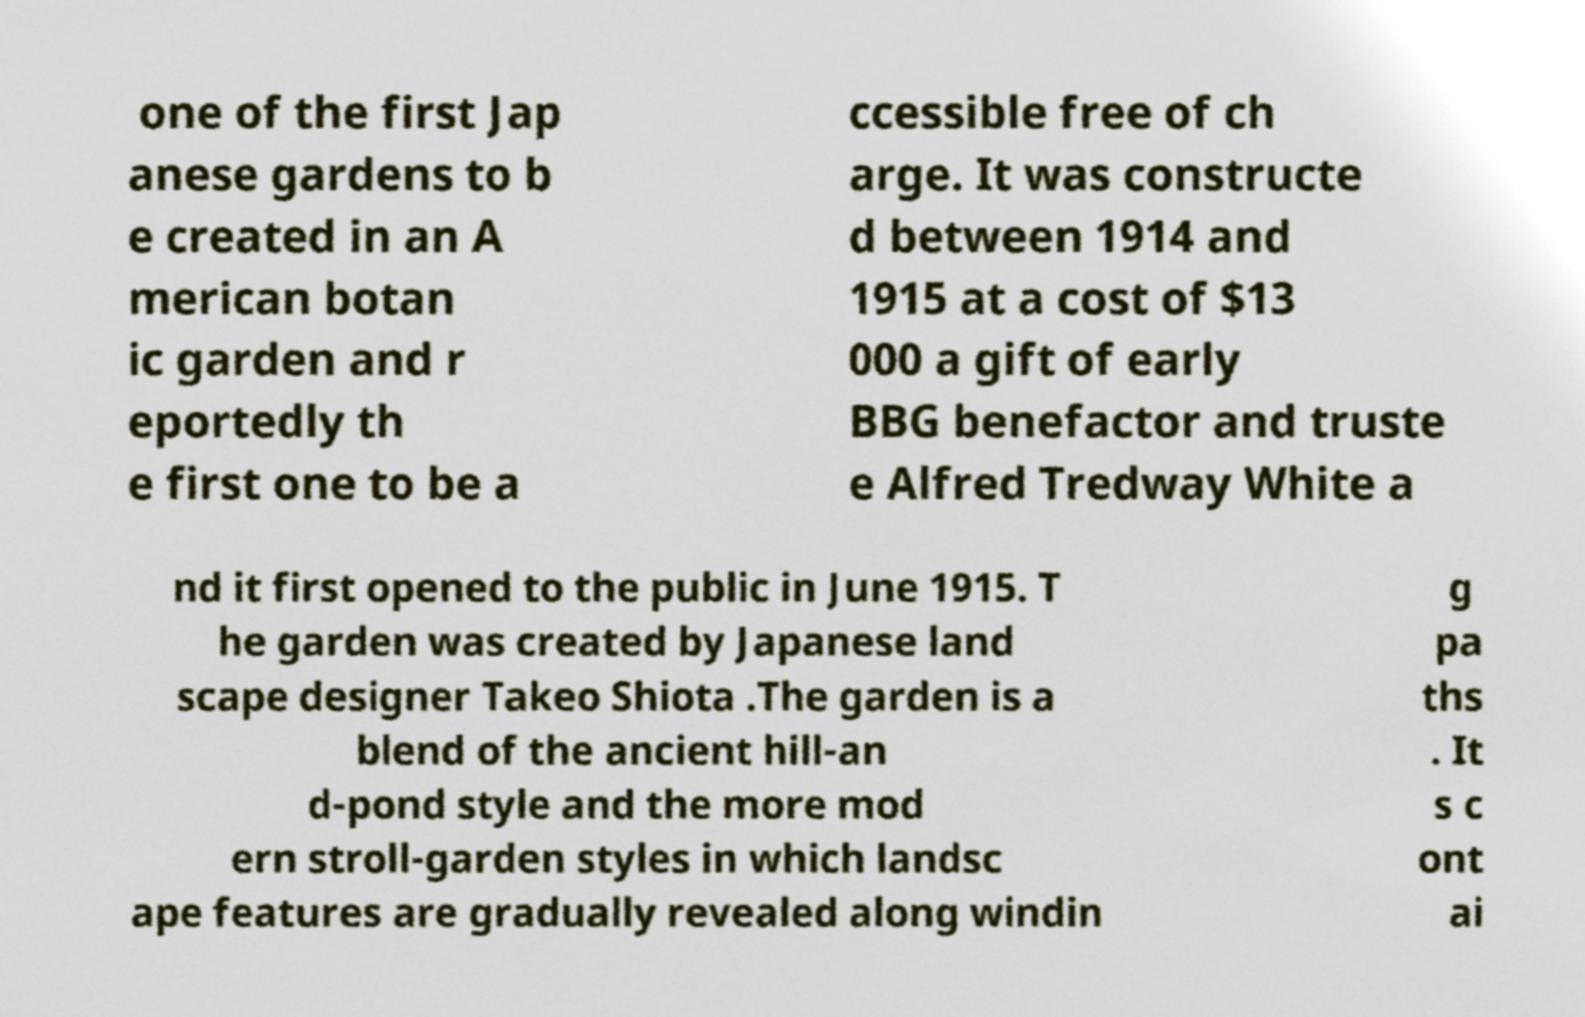For documentation purposes, I need the text within this image transcribed. Could you provide that? one of the first Jap anese gardens to b e created in an A merican botan ic garden and r eportedly th e first one to be a ccessible free of ch arge. It was constructe d between 1914 and 1915 at a cost of $13 000 a gift of early BBG benefactor and truste e Alfred Tredway White a nd it first opened to the public in June 1915. T he garden was created by Japanese land scape designer Takeo Shiota .The garden is a blend of the ancient hill-an d-pond style and the more mod ern stroll-garden styles in which landsc ape features are gradually revealed along windin g pa ths . It s c ont ai 